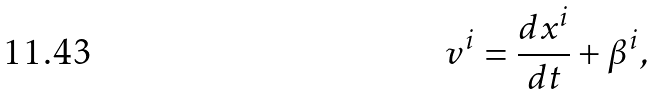Convert formula to latex. <formula><loc_0><loc_0><loc_500><loc_500>v ^ { i } = \frac { d x ^ { i } } { d t } + \beta ^ { i } ,</formula> 